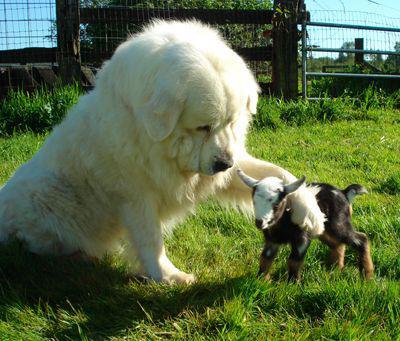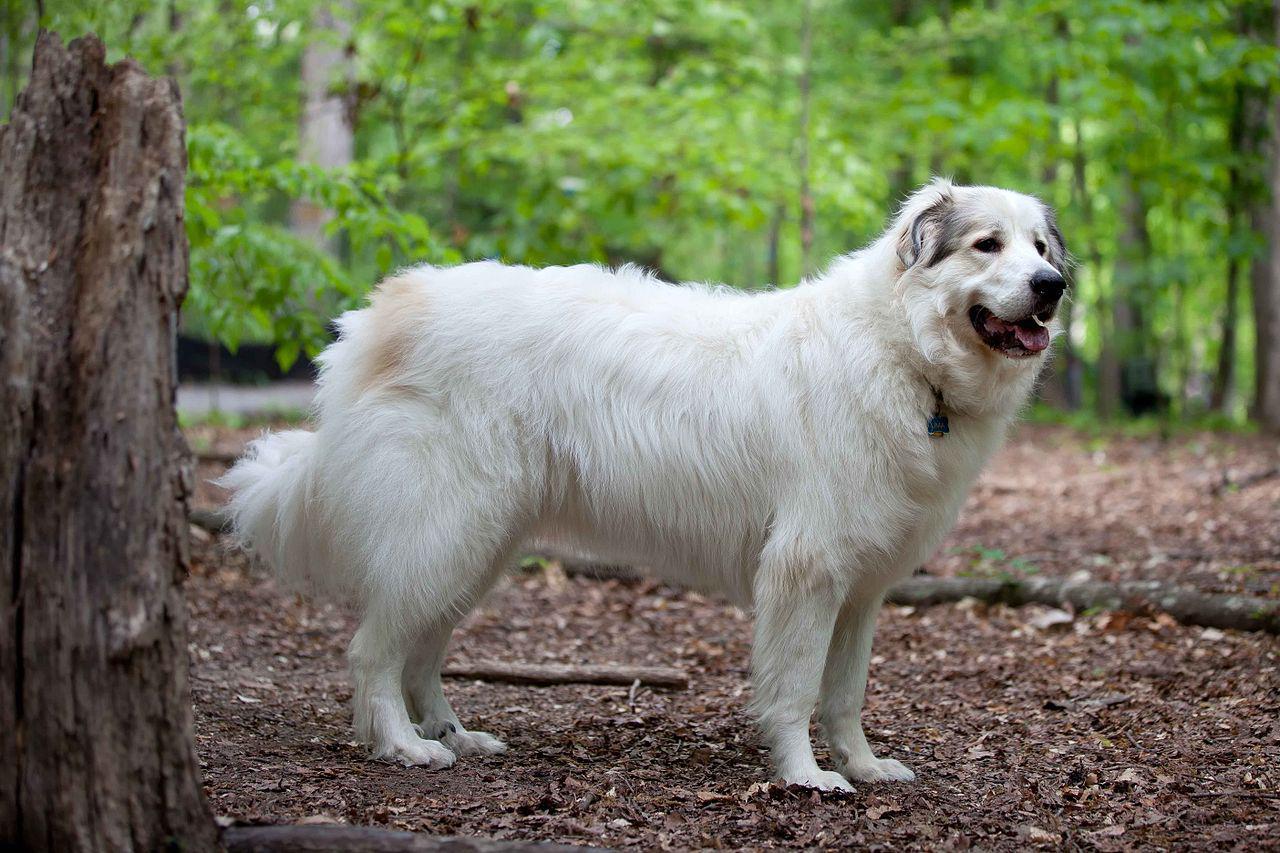The first image is the image on the left, the second image is the image on the right. Considering the images on both sides, is "the right pic has two or more dogs" valid? Answer yes or no. No. The first image is the image on the left, the second image is the image on the right. Analyze the images presented: Is the assertion "In at least one image there are exactly two dogs that are seated close together." valid? Answer yes or no. No. 